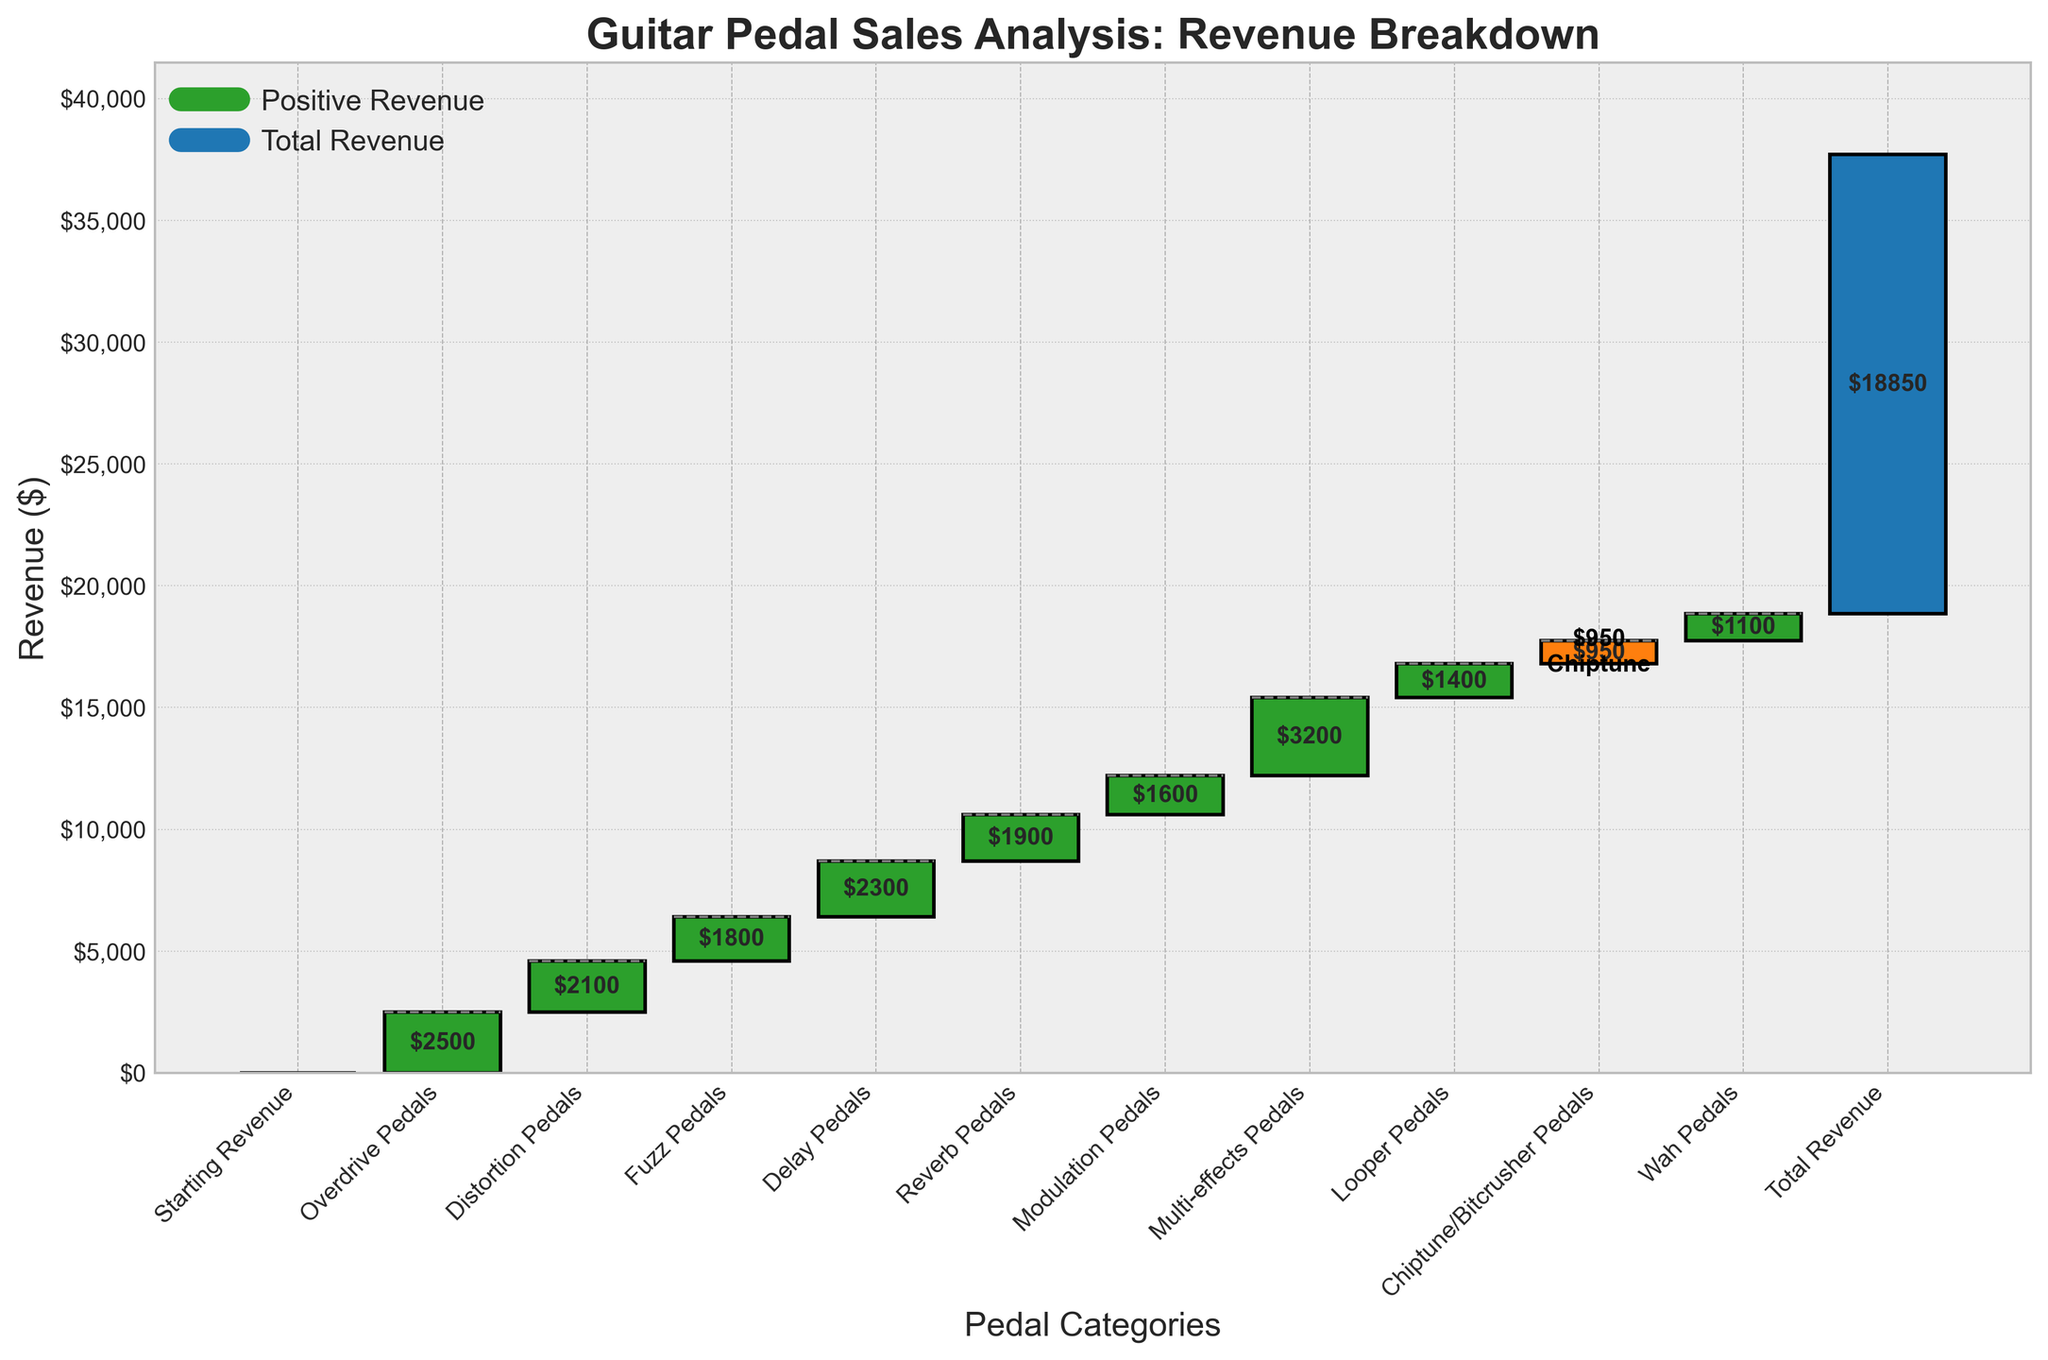What is the title of the waterfall chart? The title of the waterfall chart is prominently displayed at the top of the figure. It conveys the subject of the analysis, which is guitar pedal sales and the revenue breakdown.
Answer: Guitar Pedal Sales Analysis: Revenue Breakdown Which category has the highest revenue contribution? To find the highest revenue contribution, look for the tallest bar in the waterfall chart. Each bar represents a different category, and the height of the bar represents the revenue value.
Answer: Multi-effects Pedals How much revenue did Chiptune/Bitcrusher Pedals contribute? The revenue contribution for Chiptune/Bitcrusher Pedals can be identified from its labeled bar in the chart. The specific value is given in dollars.
Answer: $950 What is the total revenue at the end of the chart? The total revenue at the end of the chart is labeled "Total Revenue" and is marked by a special color for easy identification. The specific value is displayed at the end bar.
Answer: $18,850 How does the revenue from Reverb Pedals compare to that from Fuzz Pedals? To compare the revenue of Reverb Pedals and Fuzz Pedals, look at the height of their respective bars. Identify and compare their values.
Answer: Reverb Pedals: $1,900, Fuzz Pedals: $1,800. Reverb Pedals contribute $100 more than Fuzz Pedals What is the combined revenue of Distortion Pedals and Delay Pedals? Summing the revenue contributions of Distortion Pedals and Delay Pedals by adding their individual values gives the total combined revenue.
Answer: $4,400 Identify the pedal category with the smallest positive revenue contribution. The smallest positive revenue contribution can be found by identifying the shortest bar among those with positive values.
Answer: Chiptune/Bitcrusher Pedals What percentage of total revenue does Overdrive Pedals contribute? To find this percentage, divide the Overdrive Pedals revenue by the total revenue and multiply by 100. The formula is (Overdrive Pedals Revenue / Total Revenue) * 100.
Answer: (2,500 / 18,850) * 100 ≈ 13.27% How many pedal categories have a revenue contribution greater than $2,000? Count the number of bars that represent categories with revenue values greater than $2,000.
Answer: Four (Overdrive Pedals, Distortion Pedals, Delay Pedals, Multi-effects Pedals) What impact do Looper Pedals have on the total revenue? The impact of Looper Pedals on total revenue is shown by their bar height and value. This represents the revenue generated by this category, contributing directly to the total.
Answer: $1,400 